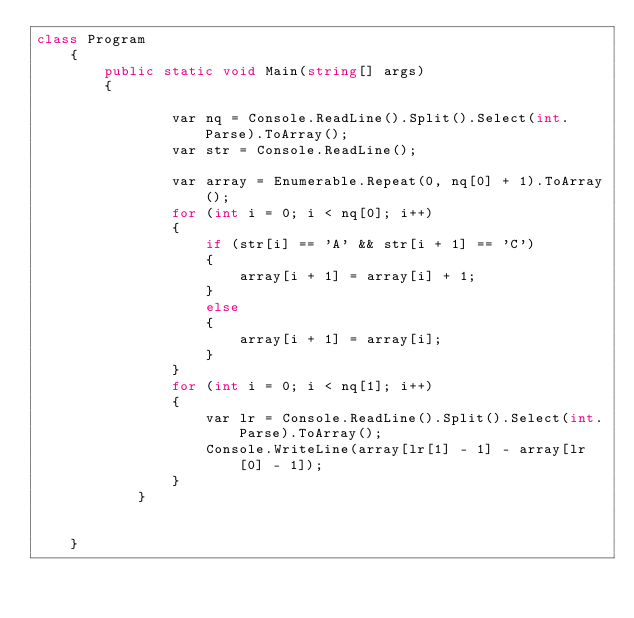Convert code to text. <code><loc_0><loc_0><loc_500><loc_500><_C#_>class Program
    {
        public static void Main(string[] args)
        {
        
                var nq = Console.ReadLine().Split().Select(int.Parse).ToArray();
                var str = Console.ReadLine();

                var array = Enumerable.Repeat(0, nq[0] + 1).ToArray();
                for (int i = 0; i < nq[0]; i++)
                {
                    if (str[i] == 'A' && str[i + 1] == 'C')
                    {
                        array[i + 1] = array[i] + 1;
                    }
                    else
                    {
                        array[i + 1] = array[i];
                    }
                }
                for (int i = 0; i < nq[1]; i++)
                {
                    var lr = Console.ReadLine().Split().Select(int.Parse).ToArray();
                    Console.WriteLine(array[lr[1] - 1] - array[lr[0] - 1]);
                }
            }
        

    }</code> 